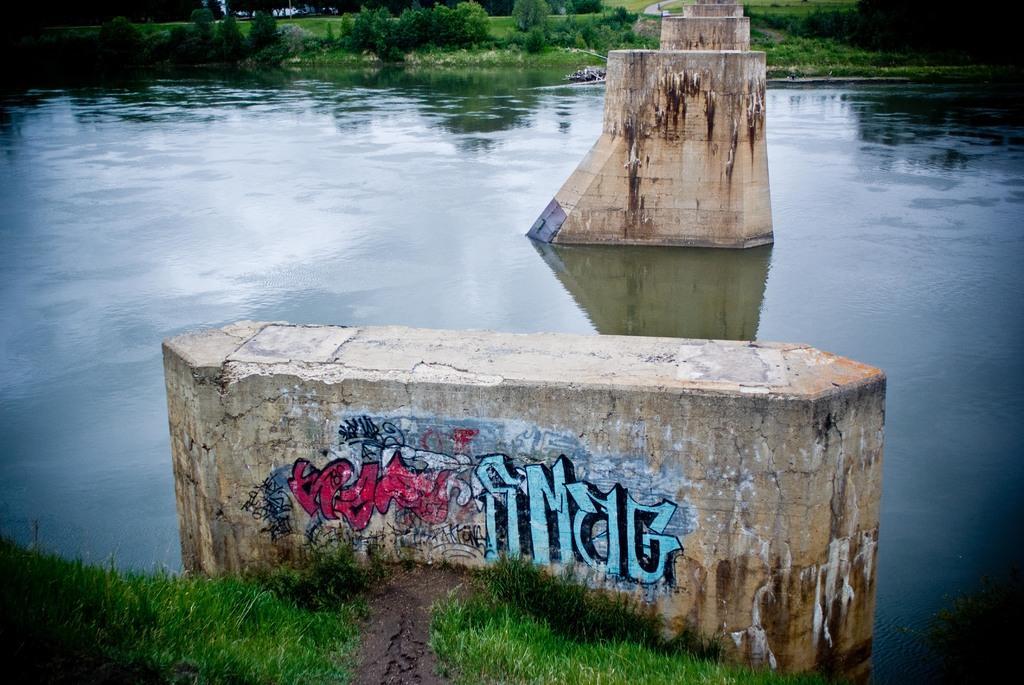In one or two sentences, can you explain what this image depicts? In the image there are pillars in the middle of lake with grassland on either side of it. 